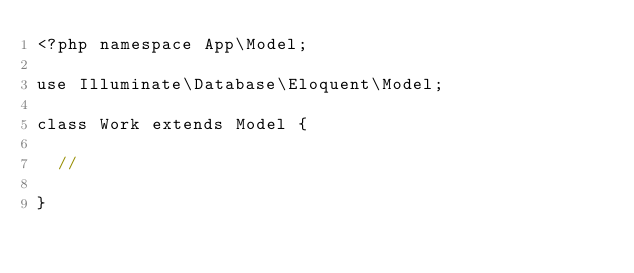<code> <loc_0><loc_0><loc_500><loc_500><_PHP_><?php namespace App\Model;

use Illuminate\Database\Eloquent\Model;

class Work extends Model {

	//

}
</code> 